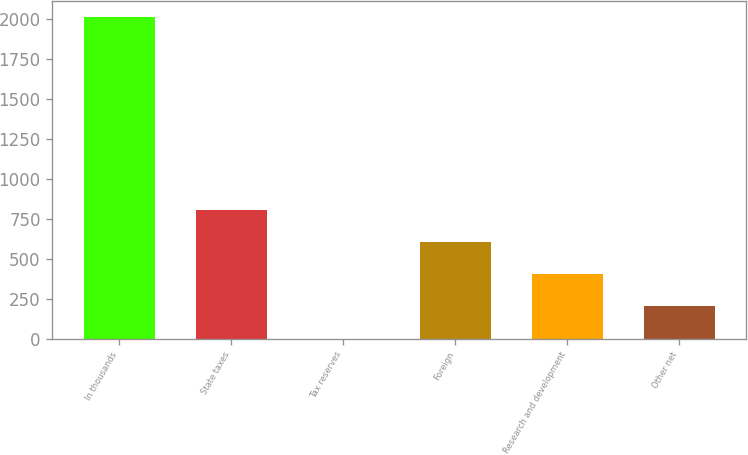Convert chart to OTSL. <chart><loc_0><loc_0><loc_500><loc_500><bar_chart><fcel>In thousands<fcel>State taxes<fcel>Tax reserves<fcel>Foreign<fcel>Research and development<fcel>Other net<nl><fcel>2010<fcel>804.12<fcel>0.2<fcel>603.14<fcel>402.16<fcel>201.18<nl></chart> 